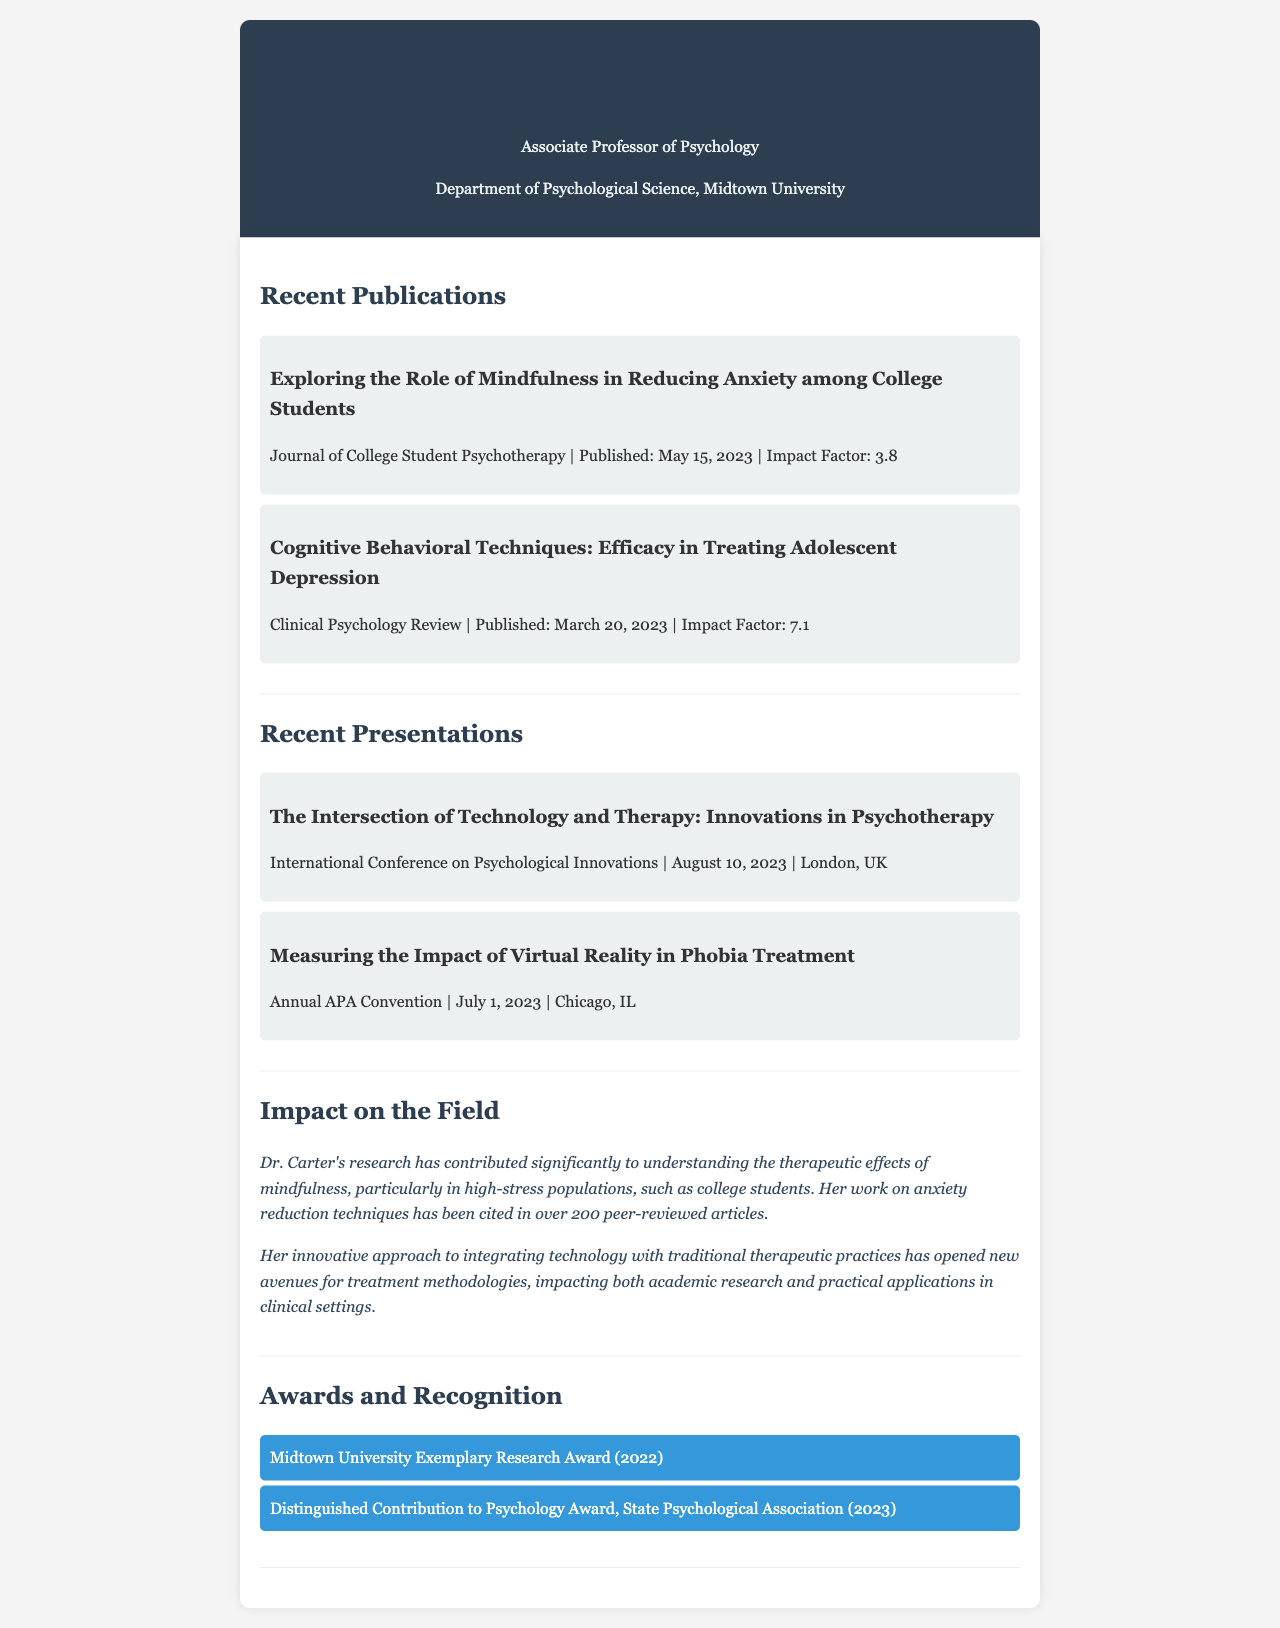What is Dr. Emily Carter's title? Dr. Emily Carter's title is mentioned in the header of the document as Associate Professor of Psychology.
Answer: Associate Professor of Psychology When was the publication "Cognitive Behavioral Techniques: Efficacy in Treating Adolescent Depression" released? The publication date is specified in the Recent Publications section, stating it was published on March 20, 2023.
Answer: March 20, 2023 How many peer-reviewed articles have cited Dr. Carter's work on anxiety reduction techniques? The document states that her work has been cited in over 200 peer-reviewed articles.
Answer: Over 200 What is the impact factor of the Journal of College Student Psychotherapy? The impact factor is provided in the publication details of the first publication in the document.
Answer: 3.8 Where did Dr. Carter present at the Annual APA Convention? The location of the presentation is mentioned in the Recent Presentations section.
Answer: Chicago, IL What award did Dr. Carter receive in 2022? The document lists specific awards under Awards and Recognition, revealing she received the Midtown University Exemplary Research Award in 2022.
Answer: Midtown University Exemplary Research Award What topic did Dr. Carter address in her presentation at the International Conference on Psychological Innovations? The title of the presentation provides this information, focusing on innovations in psychotherapy.
Answer: Innovations in Psychotherapy How has Dr. Carter's research impacted treatment methodologies? The document elaborates that her innovative approach has opened new avenues for treatment methodologies, thus impacting both research and clinical applications.
Answer: Opened new avenues for treatment methodologies 